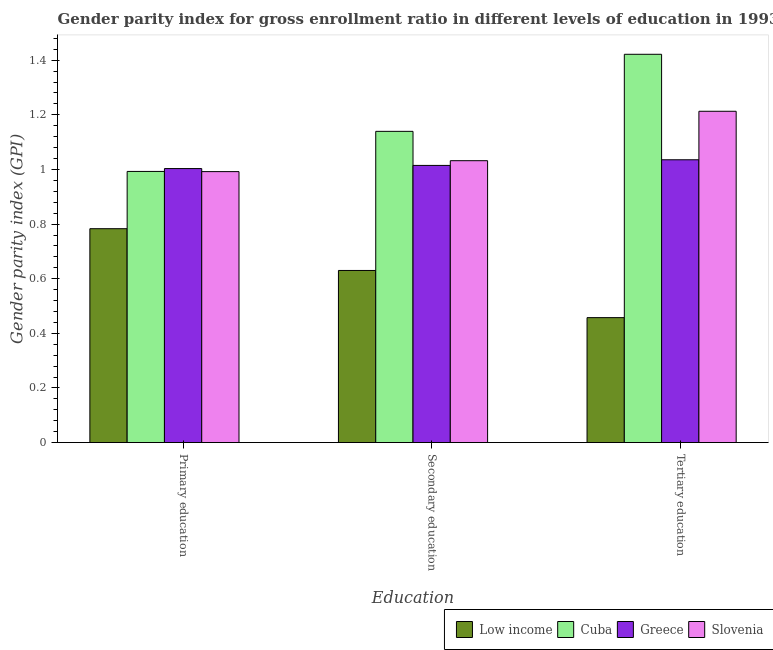How many groups of bars are there?
Your response must be concise. 3. Are the number of bars per tick equal to the number of legend labels?
Keep it short and to the point. Yes. Are the number of bars on each tick of the X-axis equal?
Provide a succinct answer. Yes. How many bars are there on the 2nd tick from the left?
Your response must be concise. 4. What is the label of the 2nd group of bars from the left?
Keep it short and to the point. Secondary education. What is the gender parity index in secondary education in Greece?
Ensure brevity in your answer.  1.01. Across all countries, what is the maximum gender parity index in primary education?
Ensure brevity in your answer.  1. Across all countries, what is the minimum gender parity index in secondary education?
Ensure brevity in your answer.  0.63. In which country was the gender parity index in tertiary education maximum?
Keep it short and to the point. Cuba. What is the total gender parity index in primary education in the graph?
Your answer should be compact. 3.77. What is the difference between the gender parity index in secondary education in Low income and that in Greece?
Your answer should be compact. -0.38. What is the difference between the gender parity index in tertiary education in Greece and the gender parity index in primary education in Cuba?
Your answer should be very brief. 0.04. What is the average gender parity index in secondary education per country?
Keep it short and to the point. 0.95. What is the difference between the gender parity index in tertiary education and gender parity index in primary education in Slovenia?
Offer a very short reply. 0.22. In how many countries, is the gender parity index in secondary education greater than 1.2400000000000002 ?
Your answer should be very brief. 0. What is the ratio of the gender parity index in secondary education in Slovenia to that in Greece?
Offer a terse response. 1.02. Is the gender parity index in secondary education in Cuba less than that in Greece?
Your response must be concise. No. What is the difference between the highest and the second highest gender parity index in secondary education?
Ensure brevity in your answer.  0.11. What is the difference between the highest and the lowest gender parity index in primary education?
Provide a short and direct response. 0.22. In how many countries, is the gender parity index in tertiary education greater than the average gender parity index in tertiary education taken over all countries?
Your response must be concise. 3. Are all the bars in the graph horizontal?
Provide a succinct answer. No. What is the difference between two consecutive major ticks on the Y-axis?
Ensure brevity in your answer.  0.2. Are the values on the major ticks of Y-axis written in scientific E-notation?
Your response must be concise. No. Does the graph contain grids?
Keep it short and to the point. No. What is the title of the graph?
Provide a short and direct response. Gender parity index for gross enrollment ratio in different levels of education in 1993. What is the label or title of the X-axis?
Keep it short and to the point. Education. What is the label or title of the Y-axis?
Provide a short and direct response. Gender parity index (GPI). What is the Gender parity index (GPI) in Low income in Primary education?
Offer a very short reply. 0.78. What is the Gender parity index (GPI) in Cuba in Primary education?
Your answer should be compact. 0.99. What is the Gender parity index (GPI) of Greece in Primary education?
Ensure brevity in your answer.  1. What is the Gender parity index (GPI) of Slovenia in Primary education?
Keep it short and to the point. 0.99. What is the Gender parity index (GPI) of Low income in Secondary education?
Offer a terse response. 0.63. What is the Gender parity index (GPI) in Cuba in Secondary education?
Offer a terse response. 1.14. What is the Gender parity index (GPI) of Greece in Secondary education?
Offer a very short reply. 1.01. What is the Gender parity index (GPI) of Slovenia in Secondary education?
Keep it short and to the point. 1.03. What is the Gender parity index (GPI) in Low income in Tertiary education?
Ensure brevity in your answer.  0.46. What is the Gender parity index (GPI) in Cuba in Tertiary education?
Ensure brevity in your answer.  1.42. What is the Gender parity index (GPI) of Greece in Tertiary education?
Provide a succinct answer. 1.04. What is the Gender parity index (GPI) of Slovenia in Tertiary education?
Offer a terse response. 1.21. Across all Education, what is the maximum Gender parity index (GPI) in Low income?
Your answer should be very brief. 0.78. Across all Education, what is the maximum Gender parity index (GPI) in Cuba?
Offer a terse response. 1.42. Across all Education, what is the maximum Gender parity index (GPI) of Greece?
Give a very brief answer. 1.04. Across all Education, what is the maximum Gender parity index (GPI) in Slovenia?
Your response must be concise. 1.21. Across all Education, what is the minimum Gender parity index (GPI) in Low income?
Ensure brevity in your answer.  0.46. Across all Education, what is the minimum Gender parity index (GPI) in Cuba?
Your answer should be very brief. 0.99. Across all Education, what is the minimum Gender parity index (GPI) in Greece?
Offer a very short reply. 1. Across all Education, what is the minimum Gender parity index (GPI) in Slovenia?
Keep it short and to the point. 0.99. What is the total Gender parity index (GPI) in Low income in the graph?
Give a very brief answer. 1.87. What is the total Gender parity index (GPI) in Cuba in the graph?
Keep it short and to the point. 3.55. What is the total Gender parity index (GPI) of Greece in the graph?
Provide a short and direct response. 3.05. What is the total Gender parity index (GPI) of Slovenia in the graph?
Provide a succinct answer. 3.24. What is the difference between the Gender parity index (GPI) of Low income in Primary education and that in Secondary education?
Your answer should be very brief. 0.15. What is the difference between the Gender parity index (GPI) in Cuba in Primary education and that in Secondary education?
Ensure brevity in your answer.  -0.15. What is the difference between the Gender parity index (GPI) in Greece in Primary education and that in Secondary education?
Your answer should be very brief. -0.01. What is the difference between the Gender parity index (GPI) in Slovenia in Primary education and that in Secondary education?
Your response must be concise. -0.04. What is the difference between the Gender parity index (GPI) of Low income in Primary education and that in Tertiary education?
Keep it short and to the point. 0.33. What is the difference between the Gender parity index (GPI) in Cuba in Primary education and that in Tertiary education?
Offer a terse response. -0.43. What is the difference between the Gender parity index (GPI) of Greece in Primary education and that in Tertiary education?
Offer a terse response. -0.03. What is the difference between the Gender parity index (GPI) in Slovenia in Primary education and that in Tertiary education?
Provide a succinct answer. -0.22. What is the difference between the Gender parity index (GPI) in Low income in Secondary education and that in Tertiary education?
Offer a terse response. 0.17. What is the difference between the Gender parity index (GPI) in Cuba in Secondary education and that in Tertiary education?
Give a very brief answer. -0.28. What is the difference between the Gender parity index (GPI) in Greece in Secondary education and that in Tertiary education?
Your answer should be very brief. -0.02. What is the difference between the Gender parity index (GPI) in Slovenia in Secondary education and that in Tertiary education?
Offer a terse response. -0.18. What is the difference between the Gender parity index (GPI) in Low income in Primary education and the Gender parity index (GPI) in Cuba in Secondary education?
Your answer should be very brief. -0.36. What is the difference between the Gender parity index (GPI) of Low income in Primary education and the Gender parity index (GPI) of Greece in Secondary education?
Provide a short and direct response. -0.23. What is the difference between the Gender parity index (GPI) of Low income in Primary education and the Gender parity index (GPI) of Slovenia in Secondary education?
Provide a short and direct response. -0.25. What is the difference between the Gender parity index (GPI) of Cuba in Primary education and the Gender parity index (GPI) of Greece in Secondary education?
Make the answer very short. -0.02. What is the difference between the Gender parity index (GPI) in Cuba in Primary education and the Gender parity index (GPI) in Slovenia in Secondary education?
Provide a short and direct response. -0.04. What is the difference between the Gender parity index (GPI) of Greece in Primary education and the Gender parity index (GPI) of Slovenia in Secondary education?
Your answer should be very brief. -0.03. What is the difference between the Gender parity index (GPI) in Low income in Primary education and the Gender parity index (GPI) in Cuba in Tertiary education?
Your answer should be very brief. -0.64. What is the difference between the Gender parity index (GPI) in Low income in Primary education and the Gender parity index (GPI) in Greece in Tertiary education?
Give a very brief answer. -0.25. What is the difference between the Gender parity index (GPI) in Low income in Primary education and the Gender parity index (GPI) in Slovenia in Tertiary education?
Provide a succinct answer. -0.43. What is the difference between the Gender parity index (GPI) of Cuba in Primary education and the Gender parity index (GPI) of Greece in Tertiary education?
Your response must be concise. -0.04. What is the difference between the Gender parity index (GPI) in Cuba in Primary education and the Gender parity index (GPI) in Slovenia in Tertiary education?
Offer a terse response. -0.22. What is the difference between the Gender parity index (GPI) in Greece in Primary education and the Gender parity index (GPI) in Slovenia in Tertiary education?
Provide a short and direct response. -0.21. What is the difference between the Gender parity index (GPI) of Low income in Secondary education and the Gender parity index (GPI) of Cuba in Tertiary education?
Make the answer very short. -0.79. What is the difference between the Gender parity index (GPI) of Low income in Secondary education and the Gender parity index (GPI) of Greece in Tertiary education?
Your answer should be very brief. -0.41. What is the difference between the Gender parity index (GPI) of Low income in Secondary education and the Gender parity index (GPI) of Slovenia in Tertiary education?
Your answer should be very brief. -0.58. What is the difference between the Gender parity index (GPI) in Cuba in Secondary education and the Gender parity index (GPI) in Greece in Tertiary education?
Give a very brief answer. 0.1. What is the difference between the Gender parity index (GPI) in Cuba in Secondary education and the Gender parity index (GPI) in Slovenia in Tertiary education?
Your answer should be very brief. -0.07. What is the difference between the Gender parity index (GPI) in Greece in Secondary education and the Gender parity index (GPI) in Slovenia in Tertiary education?
Your response must be concise. -0.2. What is the average Gender parity index (GPI) of Low income per Education?
Your answer should be compact. 0.62. What is the average Gender parity index (GPI) in Cuba per Education?
Offer a very short reply. 1.18. What is the average Gender parity index (GPI) of Greece per Education?
Your answer should be very brief. 1.02. What is the average Gender parity index (GPI) of Slovenia per Education?
Keep it short and to the point. 1.08. What is the difference between the Gender parity index (GPI) of Low income and Gender parity index (GPI) of Cuba in Primary education?
Offer a very short reply. -0.21. What is the difference between the Gender parity index (GPI) of Low income and Gender parity index (GPI) of Greece in Primary education?
Your response must be concise. -0.22. What is the difference between the Gender parity index (GPI) in Low income and Gender parity index (GPI) in Slovenia in Primary education?
Make the answer very short. -0.21. What is the difference between the Gender parity index (GPI) of Cuba and Gender parity index (GPI) of Greece in Primary education?
Your answer should be very brief. -0.01. What is the difference between the Gender parity index (GPI) of Cuba and Gender parity index (GPI) of Slovenia in Primary education?
Your answer should be compact. 0. What is the difference between the Gender parity index (GPI) in Greece and Gender parity index (GPI) in Slovenia in Primary education?
Ensure brevity in your answer.  0.01. What is the difference between the Gender parity index (GPI) of Low income and Gender parity index (GPI) of Cuba in Secondary education?
Make the answer very short. -0.51. What is the difference between the Gender parity index (GPI) in Low income and Gender parity index (GPI) in Greece in Secondary education?
Ensure brevity in your answer.  -0.38. What is the difference between the Gender parity index (GPI) in Low income and Gender parity index (GPI) in Slovenia in Secondary education?
Ensure brevity in your answer.  -0.4. What is the difference between the Gender parity index (GPI) of Cuba and Gender parity index (GPI) of Greece in Secondary education?
Your response must be concise. 0.12. What is the difference between the Gender parity index (GPI) in Cuba and Gender parity index (GPI) in Slovenia in Secondary education?
Your response must be concise. 0.11. What is the difference between the Gender parity index (GPI) of Greece and Gender parity index (GPI) of Slovenia in Secondary education?
Provide a succinct answer. -0.02. What is the difference between the Gender parity index (GPI) in Low income and Gender parity index (GPI) in Cuba in Tertiary education?
Make the answer very short. -0.96. What is the difference between the Gender parity index (GPI) of Low income and Gender parity index (GPI) of Greece in Tertiary education?
Your answer should be very brief. -0.58. What is the difference between the Gender parity index (GPI) of Low income and Gender parity index (GPI) of Slovenia in Tertiary education?
Give a very brief answer. -0.76. What is the difference between the Gender parity index (GPI) of Cuba and Gender parity index (GPI) of Greece in Tertiary education?
Offer a very short reply. 0.39. What is the difference between the Gender parity index (GPI) in Cuba and Gender parity index (GPI) in Slovenia in Tertiary education?
Your response must be concise. 0.21. What is the difference between the Gender parity index (GPI) in Greece and Gender parity index (GPI) in Slovenia in Tertiary education?
Keep it short and to the point. -0.18. What is the ratio of the Gender parity index (GPI) in Low income in Primary education to that in Secondary education?
Provide a succinct answer. 1.24. What is the ratio of the Gender parity index (GPI) in Cuba in Primary education to that in Secondary education?
Keep it short and to the point. 0.87. What is the ratio of the Gender parity index (GPI) of Slovenia in Primary education to that in Secondary education?
Keep it short and to the point. 0.96. What is the ratio of the Gender parity index (GPI) in Low income in Primary education to that in Tertiary education?
Offer a very short reply. 1.71. What is the ratio of the Gender parity index (GPI) of Cuba in Primary education to that in Tertiary education?
Your answer should be very brief. 0.7. What is the ratio of the Gender parity index (GPI) of Greece in Primary education to that in Tertiary education?
Your answer should be very brief. 0.97. What is the ratio of the Gender parity index (GPI) of Slovenia in Primary education to that in Tertiary education?
Provide a succinct answer. 0.82. What is the ratio of the Gender parity index (GPI) in Low income in Secondary education to that in Tertiary education?
Make the answer very short. 1.38. What is the ratio of the Gender parity index (GPI) in Cuba in Secondary education to that in Tertiary education?
Offer a very short reply. 0.8. What is the ratio of the Gender parity index (GPI) of Greece in Secondary education to that in Tertiary education?
Give a very brief answer. 0.98. What is the ratio of the Gender parity index (GPI) of Slovenia in Secondary education to that in Tertiary education?
Keep it short and to the point. 0.85. What is the difference between the highest and the second highest Gender parity index (GPI) of Low income?
Your answer should be compact. 0.15. What is the difference between the highest and the second highest Gender parity index (GPI) in Cuba?
Ensure brevity in your answer.  0.28. What is the difference between the highest and the second highest Gender parity index (GPI) in Greece?
Provide a succinct answer. 0.02. What is the difference between the highest and the second highest Gender parity index (GPI) in Slovenia?
Offer a terse response. 0.18. What is the difference between the highest and the lowest Gender parity index (GPI) in Low income?
Offer a very short reply. 0.33. What is the difference between the highest and the lowest Gender parity index (GPI) in Cuba?
Offer a very short reply. 0.43. What is the difference between the highest and the lowest Gender parity index (GPI) in Greece?
Offer a terse response. 0.03. What is the difference between the highest and the lowest Gender parity index (GPI) in Slovenia?
Provide a succinct answer. 0.22. 